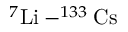Convert formula to latex. <formula><loc_0><loc_0><loc_500><loc_500>^ { 7 } { L i } - ^ { 1 3 3 } { C s }</formula> 